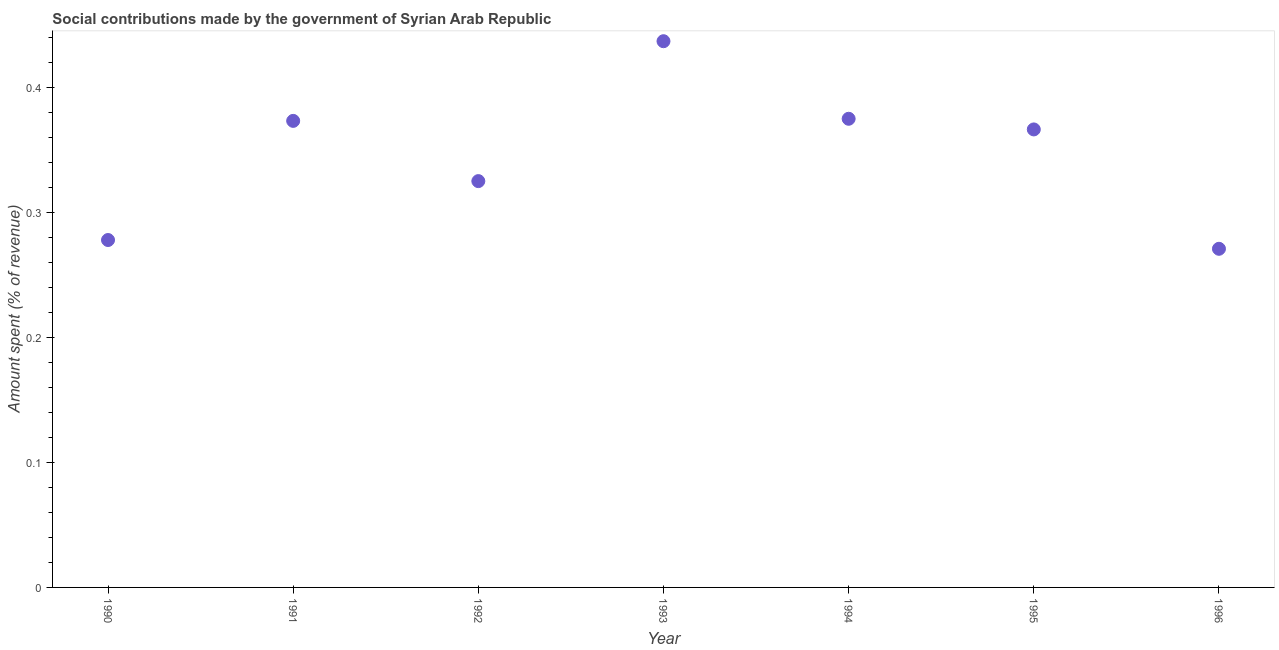What is the amount spent in making social contributions in 1996?
Offer a terse response. 0.27. Across all years, what is the maximum amount spent in making social contributions?
Give a very brief answer. 0.44. Across all years, what is the minimum amount spent in making social contributions?
Provide a short and direct response. 0.27. What is the sum of the amount spent in making social contributions?
Your answer should be compact. 2.42. What is the difference between the amount spent in making social contributions in 1992 and 1996?
Your response must be concise. 0.05. What is the average amount spent in making social contributions per year?
Offer a very short reply. 0.35. What is the median amount spent in making social contributions?
Offer a terse response. 0.37. Do a majority of the years between 1990 and 1995 (inclusive) have amount spent in making social contributions greater than 0.14 %?
Keep it short and to the point. Yes. What is the ratio of the amount spent in making social contributions in 1994 to that in 1995?
Offer a very short reply. 1.02. Is the amount spent in making social contributions in 1992 less than that in 1996?
Offer a terse response. No. What is the difference between the highest and the second highest amount spent in making social contributions?
Give a very brief answer. 0.06. Is the sum of the amount spent in making social contributions in 1990 and 1995 greater than the maximum amount spent in making social contributions across all years?
Provide a succinct answer. Yes. What is the difference between the highest and the lowest amount spent in making social contributions?
Provide a succinct answer. 0.17. In how many years, is the amount spent in making social contributions greater than the average amount spent in making social contributions taken over all years?
Offer a terse response. 4. Does the amount spent in making social contributions monotonically increase over the years?
Ensure brevity in your answer.  No. What is the title of the graph?
Make the answer very short. Social contributions made by the government of Syrian Arab Republic. What is the label or title of the X-axis?
Your answer should be very brief. Year. What is the label or title of the Y-axis?
Offer a very short reply. Amount spent (% of revenue). What is the Amount spent (% of revenue) in 1990?
Provide a succinct answer. 0.28. What is the Amount spent (% of revenue) in 1991?
Ensure brevity in your answer.  0.37. What is the Amount spent (% of revenue) in 1992?
Your answer should be very brief. 0.32. What is the Amount spent (% of revenue) in 1993?
Keep it short and to the point. 0.44. What is the Amount spent (% of revenue) in 1994?
Offer a very short reply. 0.37. What is the Amount spent (% of revenue) in 1995?
Keep it short and to the point. 0.37. What is the Amount spent (% of revenue) in 1996?
Ensure brevity in your answer.  0.27. What is the difference between the Amount spent (% of revenue) in 1990 and 1991?
Offer a terse response. -0.1. What is the difference between the Amount spent (% of revenue) in 1990 and 1992?
Your response must be concise. -0.05. What is the difference between the Amount spent (% of revenue) in 1990 and 1993?
Provide a succinct answer. -0.16. What is the difference between the Amount spent (% of revenue) in 1990 and 1994?
Ensure brevity in your answer.  -0.1. What is the difference between the Amount spent (% of revenue) in 1990 and 1995?
Offer a very short reply. -0.09. What is the difference between the Amount spent (% of revenue) in 1990 and 1996?
Your answer should be very brief. 0.01. What is the difference between the Amount spent (% of revenue) in 1991 and 1992?
Give a very brief answer. 0.05. What is the difference between the Amount spent (% of revenue) in 1991 and 1993?
Make the answer very short. -0.06. What is the difference between the Amount spent (% of revenue) in 1991 and 1994?
Your answer should be compact. -0. What is the difference between the Amount spent (% of revenue) in 1991 and 1995?
Keep it short and to the point. 0.01. What is the difference between the Amount spent (% of revenue) in 1991 and 1996?
Give a very brief answer. 0.1. What is the difference between the Amount spent (% of revenue) in 1992 and 1993?
Ensure brevity in your answer.  -0.11. What is the difference between the Amount spent (% of revenue) in 1992 and 1994?
Provide a succinct answer. -0.05. What is the difference between the Amount spent (% of revenue) in 1992 and 1995?
Offer a very short reply. -0.04. What is the difference between the Amount spent (% of revenue) in 1992 and 1996?
Make the answer very short. 0.05. What is the difference between the Amount spent (% of revenue) in 1993 and 1994?
Make the answer very short. 0.06. What is the difference between the Amount spent (% of revenue) in 1993 and 1995?
Ensure brevity in your answer.  0.07. What is the difference between the Amount spent (% of revenue) in 1993 and 1996?
Provide a succinct answer. 0.17. What is the difference between the Amount spent (% of revenue) in 1994 and 1995?
Ensure brevity in your answer.  0.01. What is the difference between the Amount spent (% of revenue) in 1994 and 1996?
Offer a terse response. 0.1. What is the difference between the Amount spent (% of revenue) in 1995 and 1996?
Your answer should be compact. 0.1. What is the ratio of the Amount spent (% of revenue) in 1990 to that in 1991?
Give a very brief answer. 0.74. What is the ratio of the Amount spent (% of revenue) in 1990 to that in 1992?
Ensure brevity in your answer.  0.85. What is the ratio of the Amount spent (% of revenue) in 1990 to that in 1993?
Give a very brief answer. 0.64. What is the ratio of the Amount spent (% of revenue) in 1990 to that in 1994?
Provide a short and direct response. 0.74. What is the ratio of the Amount spent (% of revenue) in 1990 to that in 1995?
Offer a terse response. 0.76. What is the ratio of the Amount spent (% of revenue) in 1991 to that in 1992?
Offer a terse response. 1.15. What is the ratio of the Amount spent (% of revenue) in 1991 to that in 1993?
Provide a succinct answer. 0.85. What is the ratio of the Amount spent (% of revenue) in 1991 to that in 1994?
Give a very brief answer. 1. What is the ratio of the Amount spent (% of revenue) in 1991 to that in 1995?
Offer a very short reply. 1.02. What is the ratio of the Amount spent (% of revenue) in 1991 to that in 1996?
Keep it short and to the point. 1.38. What is the ratio of the Amount spent (% of revenue) in 1992 to that in 1993?
Provide a succinct answer. 0.74. What is the ratio of the Amount spent (% of revenue) in 1992 to that in 1994?
Make the answer very short. 0.87. What is the ratio of the Amount spent (% of revenue) in 1992 to that in 1995?
Offer a terse response. 0.89. What is the ratio of the Amount spent (% of revenue) in 1993 to that in 1994?
Make the answer very short. 1.17. What is the ratio of the Amount spent (% of revenue) in 1993 to that in 1995?
Ensure brevity in your answer.  1.19. What is the ratio of the Amount spent (% of revenue) in 1993 to that in 1996?
Provide a succinct answer. 1.61. What is the ratio of the Amount spent (% of revenue) in 1994 to that in 1996?
Provide a succinct answer. 1.38. What is the ratio of the Amount spent (% of revenue) in 1995 to that in 1996?
Your answer should be very brief. 1.35. 